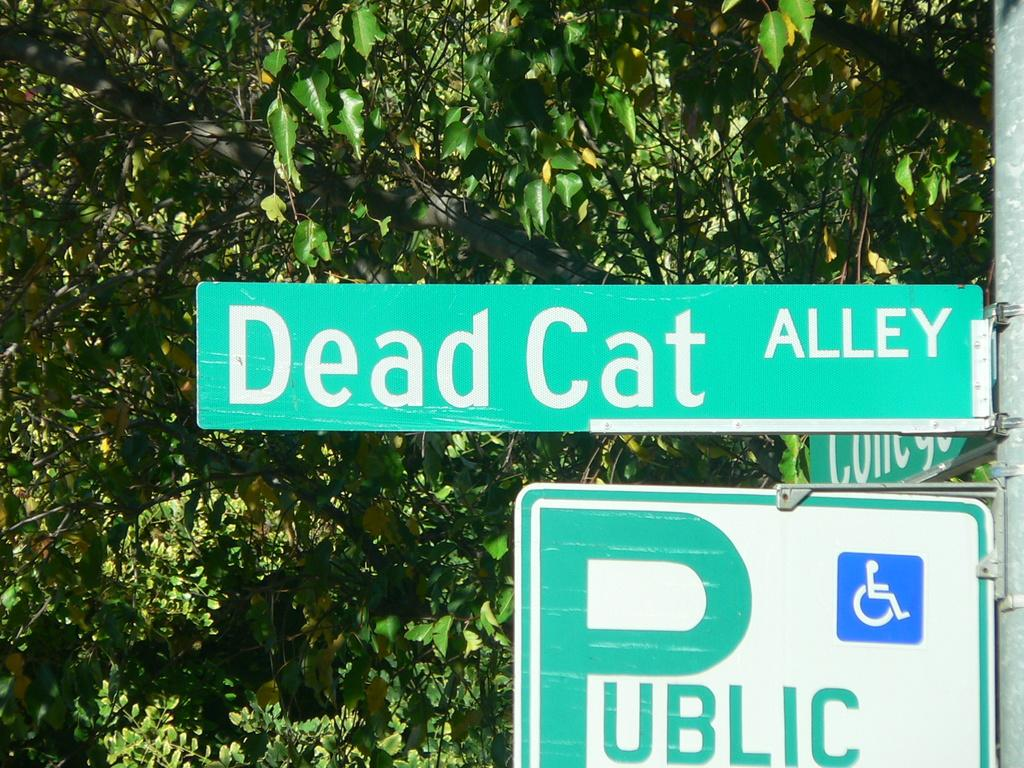<image>
Provide a brief description of the given image. A street sign bears the name "Dead Cat Alley." 